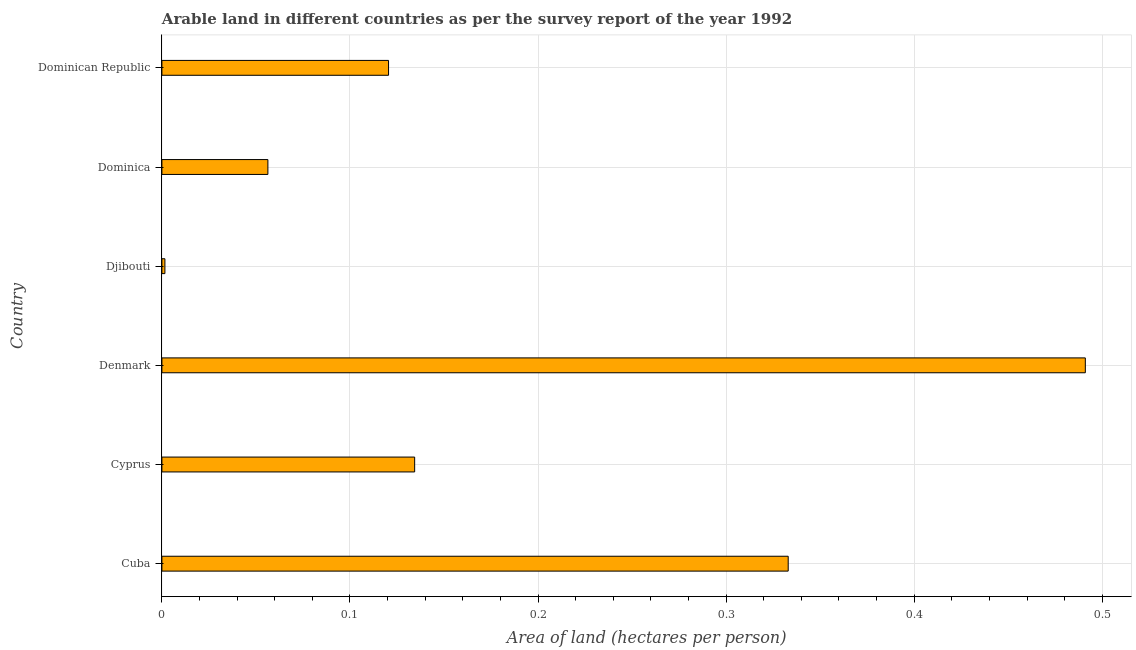What is the title of the graph?
Provide a succinct answer. Arable land in different countries as per the survey report of the year 1992. What is the label or title of the X-axis?
Make the answer very short. Area of land (hectares per person). What is the area of arable land in Dominica?
Provide a short and direct response. 0.06. Across all countries, what is the maximum area of arable land?
Keep it short and to the point. 0.49. Across all countries, what is the minimum area of arable land?
Offer a terse response. 0. In which country was the area of arable land minimum?
Ensure brevity in your answer.  Djibouti. What is the sum of the area of arable land?
Your answer should be very brief. 1.14. What is the difference between the area of arable land in Cyprus and Dominican Republic?
Your answer should be compact. 0.01. What is the average area of arable land per country?
Make the answer very short. 0.19. What is the median area of arable land?
Give a very brief answer. 0.13. In how many countries, is the area of arable land greater than 0.02 hectares per person?
Offer a very short reply. 5. What is the ratio of the area of arable land in Cyprus to that in Denmark?
Keep it short and to the point. 0.27. What is the difference between the highest and the second highest area of arable land?
Keep it short and to the point. 0.16. Is the sum of the area of arable land in Cyprus and Djibouti greater than the maximum area of arable land across all countries?
Your answer should be very brief. No. What is the difference between the highest and the lowest area of arable land?
Your answer should be very brief. 0.49. In how many countries, is the area of arable land greater than the average area of arable land taken over all countries?
Offer a terse response. 2. Are the values on the major ticks of X-axis written in scientific E-notation?
Give a very brief answer. No. What is the Area of land (hectares per person) in Cuba?
Make the answer very short. 0.33. What is the Area of land (hectares per person) of Cyprus?
Offer a terse response. 0.13. What is the Area of land (hectares per person) in Denmark?
Keep it short and to the point. 0.49. What is the Area of land (hectares per person) in Djibouti?
Offer a very short reply. 0. What is the Area of land (hectares per person) of Dominica?
Provide a short and direct response. 0.06. What is the Area of land (hectares per person) of Dominican Republic?
Your answer should be very brief. 0.12. What is the difference between the Area of land (hectares per person) in Cuba and Cyprus?
Your answer should be very brief. 0.2. What is the difference between the Area of land (hectares per person) in Cuba and Denmark?
Your answer should be very brief. -0.16. What is the difference between the Area of land (hectares per person) in Cuba and Djibouti?
Give a very brief answer. 0.33. What is the difference between the Area of land (hectares per person) in Cuba and Dominica?
Your response must be concise. 0.28. What is the difference between the Area of land (hectares per person) in Cuba and Dominican Republic?
Provide a succinct answer. 0.21. What is the difference between the Area of land (hectares per person) in Cyprus and Denmark?
Offer a terse response. -0.36. What is the difference between the Area of land (hectares per person) in Cyprus and Djibouti?
Give a very brief answer. 0.13. What is the difference between the Area of land (hectares per person) in Cyprus and Dominica?
Your answer should be compact. 0.08. What is the difference between the Area of land (hectares per person) in Cyprus and Dominican Republic?
Keep it short and to the point. 0.01. What is the difference between the Area of land (hectares per person) in Denmark and Djibouti?
Keep it short and to the point. 0.49. What is the difference between the Area of land (hectares per person) in Denmark and Dominica?
Offer a terse response. 0.43. What is the difference between the Area of land (hectares per person) in Denmark and Dominican Republic?
Your answer should be compact. 0.37. What is the difference between the Area of land (hectares per person) in Djibouti and Dominica?
Make the answer very short. -0.05. What is the difference between the Area of land (hectares per person) in Djibouti and Dominican Republic?
Keep it short and to the point. -0.12. What is the difference between the Area of land (hectares per person) in Dominica and Dominican Republic?
Give a very brief answer. -0.06. What is the ratio of the Area of land (hectares per person) in Cuba to that in Cyprus?
Ensure brevity in your answer.  2.48. What is the ratio of the Area of land (hectares per person) in Cuba to that in Denmark?
Keep it short and to the point. 0.68. What is the ratio of the Area of land (hectares per person) in Cuba to that in Djibouti?
Provide a short and direct response. 208.81. What is the ratio of the Area of land (hectares per person) in Cuba to that in Dominica?
Make the answer very short. 5.91. What is the ratio of the Area of land (hectares per person) in Cuba to that in Dominican Republic?
Your answer should be compact. 2.76. What is the ratio of the Area of land (hectares per person) in Cyprus to that in Denmark?
Your answer should be compact. 0.27. What is the ratio of the Area of land (hectares per person) in Cyprus to that in Djibouti?
Give a very brief answer. 84.27. What is the ratio of the Area of land (hectares per person) in Cyprus to that in Dominica?
Your answer should be very brief. 2.38. What is the ratio of the Area of land (hectares per person) in Cyprus to that in Dominican Republic?
Give a very brief answer. 1.11. What is the ratio of the Area of land (hectares per person) in Denmark to that in Djibouti?
Your response must be concise. 307.87. What is the ratio of the Area of land (hectares per person) in Denmark to that in Dominica?
Give a very brief answer. 8.71. What is the ratio of the Area of land (hectares per person) in Denmark to that in Dominican Republic?
Offer a very short reply. 4.07. What is the ratio of the Area of land (hectares per person) in Djibouti to that in Dominica?
Give a very brief answer. 0.03. What is the ratio of the Area of land (hectares per person) in Djibouti to that in Dominican Republic?
Provide a short and direct response. 0.01. What is the ratio of the Area of land (hectares per person) in Dominica to that in Dominican Republic?
Keep it short and to the point. 0.47. 